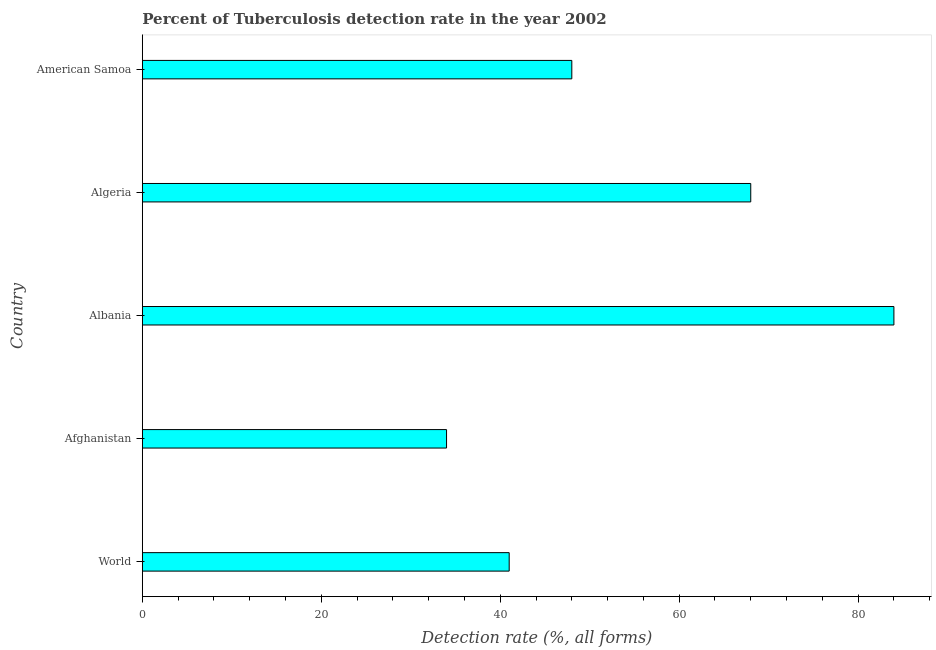What is the title of the graph?
Your answer should be very brief. Percent of Tuberculosis detection rate in the year 2002. What is the label or title of the X-axis?
Give a very brief answer. Detection rate (%, all forms). What is the label or title of the Y-axis?
Ensure brevity in your answer.  Country. What is the detection rate of tuberculosis in Algeria?
Your answer should be compact. 68. In which country was the detection rate of tuberculosis maximum?
Your answer should be compact. Albania. In which country was the detection rate of tuberculosis minimum?
Your answer should be compact. Afghanistan. What is the sum of the detection rate of tuberculosis?
Offer a very short reply. 275. What is the average detection rate of tuberculosis per country?
Offer a very short reply. 55. What is the median detection rate of tuberculosis?
Offer a very short reply. 48. In how many countries, is the detection rate of tuberculosis greater than 76 %?
Your answer should be very brief. 1. What is the difference between the highest and the second highest detection rate of tuberculosis?
Give a very brief answer. 16. Is the sum of the detection rate of tuberculosis in Afghanistan and World greater than the maximum detection rate of tuberculosis across all countries?
Offer a very short reply. No. What is the difference between the highest and the lowest detection rate of tuberculosis?
Your answer should be compact. 50. How many bars are there?
Offer a terse response. 5. Are all the bars in the graph horizontal?
Give a very brief answer. Yes. How many countries are there in the graph?
Provide a succinct answer. 5. What is the Detection rate (%, all forms) in World?
Provide a succinct answer. 41. What is the Detection rate (%, all forms) of Afghanistan?
Keep it short and to the point. 34. What is the difference between the Detection rate (%, all forms) in World and Afghanistan?
Your answer should be very brief. 7. What is the difference between the Detection rate (%, all forms) in World and Albania?
Make the answer very short. -43. What is the difference between the Detection rate (%, all forms) in World and Algeria?
Offer a terse response. -27. What is the difference between the Detection rate (%, all forms) in World and American Samoa?
Provide a succinct answer. -7. What is the difference between the Detection rate (%, all forms) in Afghanistan and Algeria?
Provide a succinct answer. -34. What is the difference between the Detection rate (%, all forms) in Albania and Algeria?
Make the answer very short. 16. What is the difference between the Detection rate (%, all forms) in Albania and American Samoa?
Make the answer very short. 36. What is the difference between the Detection rate (%, all forms) in Algeria and American Samoa?
Your response must be concise. 20. What is the ratio of the Detection rate (%, all forms) in World to that in Afghanistan?
Make the answer very short. 1.21. What is the ratio of the Detection rate (%, all forms) in World to that in Albania?
Your answer should be very brief. 0.49. What is the ratio of the Detection rate (%, all forms) in World to that in Algeria?
Ensure brevity in your answer.  0.6. What is the ratio of the Detection rate (%, all forms) in World to that in American Samoa?
Keep it short and to the point. 0.85. What is the ratio of the Detection rate (%, all forms) in Afghanistan to that in Albania?
Provide a succinct answer. 0.41. What is the ratio of the Detection rate (%, all forms) in Afghanistan to that in American Samoa?
Offer a terse response. 0.71. What is the ratio of the Detection rate (%, all forms) in Albania to that in Algeria?
Keep it short and to the point. 1.24. What is the ratio of the Detection rate (%, all forms) in Algeria to that in American Samoa?
Give a very brief answer. 1.42. 